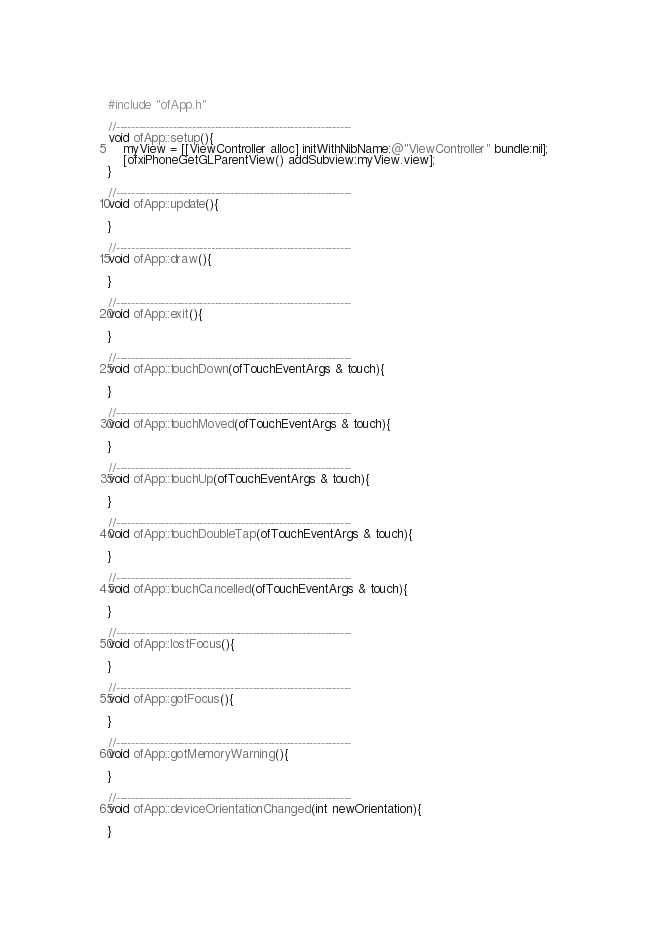<code> <loc_0><loc_0><loc_500><loc_500><_ObjectiveC_>#include "ofApp.h"

//--------------------------------------------------------------
void ofApp::setup(){	
    myView = [[ViewController alloc] initWithNibName:@"ViewController" bundle:nil];
    [ofxiPhoneGetGLParentView() addSubview:myView.view];
}

//--------------------------------------------------------------
void ofApp::update(){

}

//--------------------------------------------------------------
void ofApp::draw(){
	
}

//--------------------------------------------------------------
void ofApp::exit(){

}

//--------------------------------------------------------------
void ofApp::touchDown(ofTouchEventArgs & touch){

}

//--------------------------------------------------------------
void ofApp::touchMoved(ofTouchEventArgs & touch){

}

//--------------------------------------------------------------
void ofApp::touchUp(ofTouchEventArgs & touch){

}

//--------------------------------------------------------------
void ofApp::touchDoubleTap(ofTouchEventArgs & touch){

}

//--------------------------------------------------------------
void ofApp::touchCancelled(ofTouchEventArgs & touch){
    
}

//--------------------------------------------------------------
void ofApp::lostFocus(){

}

//--------------------------------------------------------------
void ofApp::gotFocus(){

}

//--------------------------------------------------------------
void ofApp::gotMemoryWarning(){

}

//--------------------------------------------------------------
void ofApp::deviceOrientationChanged(int newOrientation){

}
</code> 